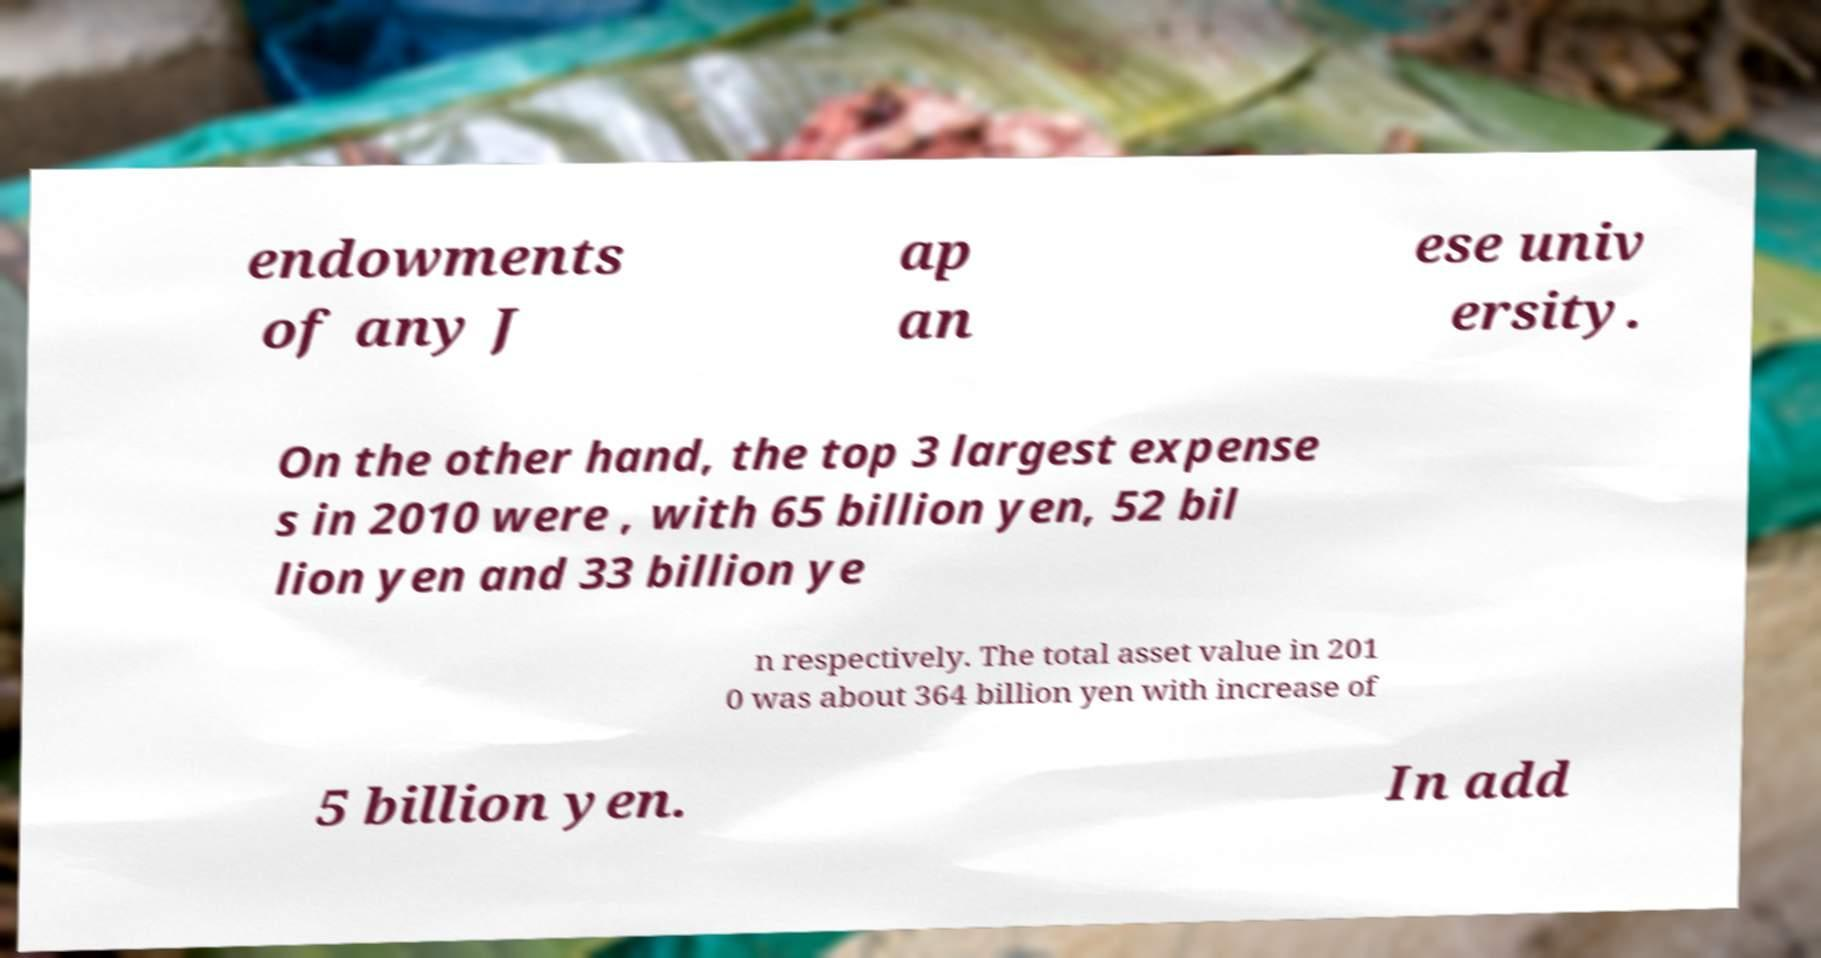Can you read and provide the text displayed in the image?This photo seems to have some interesting text. Can you extract and type it out for me? endowments of any J ap an ese univ ersity. On the other hand, the top 3 largest expense s in 2010 were , with 65 billion yen, 52 bil lion yen and 33 billion ye n respectively. The total asset value in 201 0 was about 364 billion yen with increase of 5 billion yen. In add 